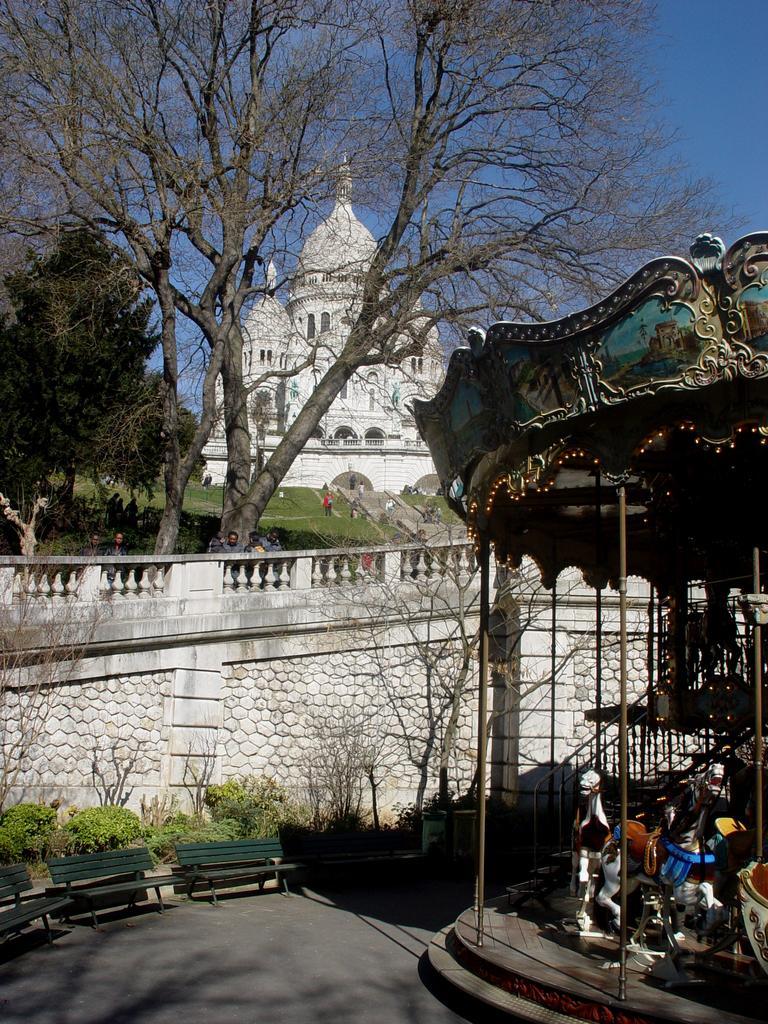Please provide a concise description of this image. This image is taken outdoors. At the top of the image there is the sky. At the bottom of the image there is a floor. On the right side of the image there is a carnival horse. There is a railing. There are a few stairs. In the middle of the image there is a wall. There are a few plants and trees on the ground. There are three empty benches on the floor. There is a ground with grass on it. A few people are standing and a few are walking on the ground. In the background there is an architecture with walls, windows, doors, carvings and sculptures. 